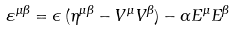<formula> <loc_0><loc_0><loc_500><loc_500>\varepsilon ^ { \mu \beta } = \epsilon \, ( \eta ^ { \mu \beta } - V ^ { \mu } V ^ { \beta } ) - \alpha E ^ { \mu } E ^ { \beta }</formula> 